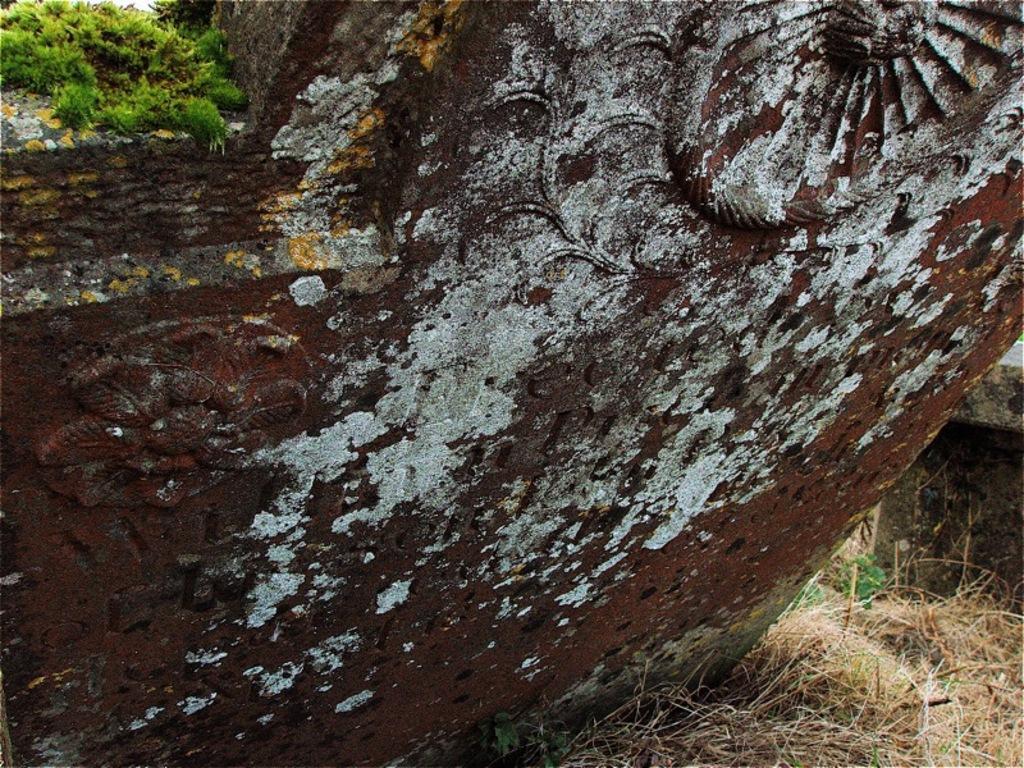In one or two sentences, can you explain what this image depicts? In this image I can see the metal object. On both sides of the metal object I can see the grass. I can see the grass is in green and brown color. 